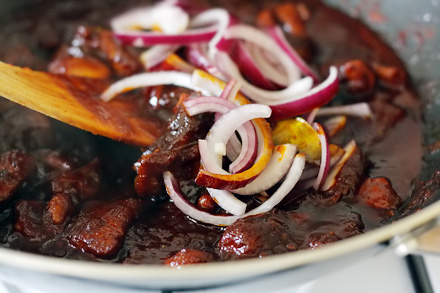<image>
Is the onion on the bowl? No. The onion is not positioned on the bowl. They may be near each other, but the onion is not supported by or resting on top of the bowl. 